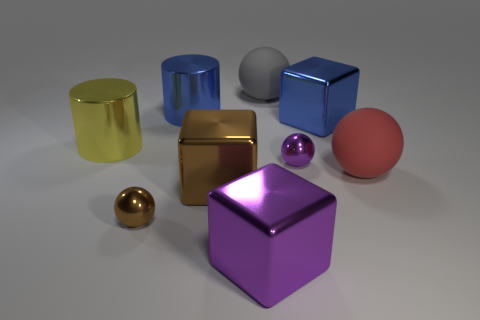What material is the ball that is left of the small purple sphere and in front of the big gray ball? metal 